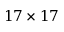<formula> <loc_0><loc_0><loc_500><loc_500>1 7 \times 1 7</formula> 